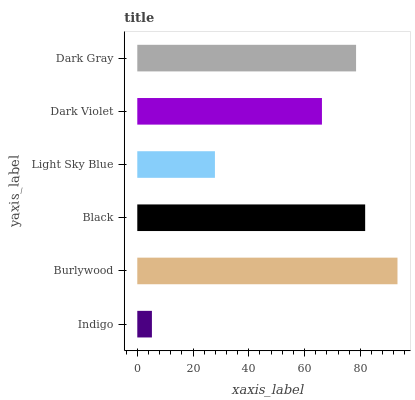Is Indigo the minimum?
Answer yes or no. Yes. Is Burlywood the maximum?
Answer yes or no. Yes. Is Black the minimum?
Answer yes or no. No. Is Black the maximum?
Answer yes or no. No. Is Burlywood greater than Black?
Answer yes or no. Yes. Is Black less than Burlywood?
Answer yes or no. Yes. Is Black greater than Burlywood?
Answer yes or no. No. Is Burlywood less than Black?
Answer yes or no. No. Is Dark Gray the high median?
Answer yes or no. Yes. Is Dark Violet the low median?
Answer yes or no. Yes. Is Burlywood the high median?
Answer yes or no. No. Is Burlywood the low median?
Answer yes or no. No. 